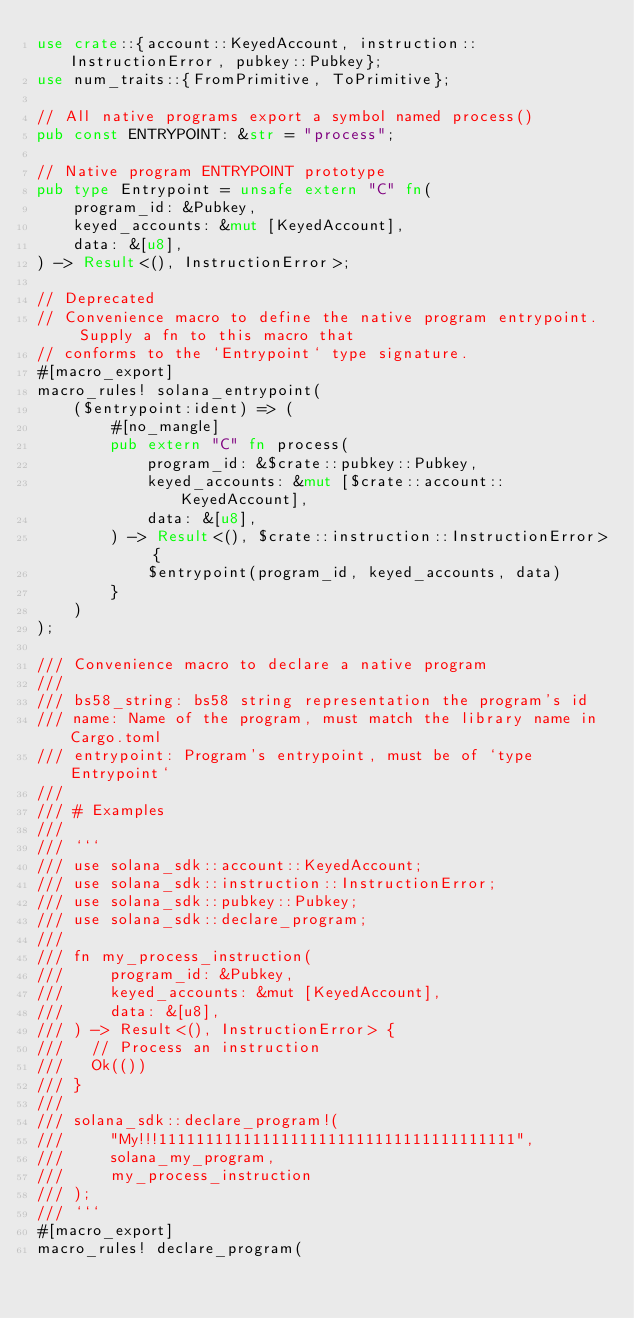<code> <loc_0><loc_0><loc_500><loc_500><_Rust_>use crate::{account::KeyedAccount, instruction::InstructionError, pubkey::Pubkey};
use num_traits::{FromPrimitive, ToPrimitive};

// All native programs export a symbol named process()
pub const ENTRYPOINT: &str = "process";

// Native program ENTRYPOINT prototype
pub type Entrypoint = unsafe extern "C" fn(
    program_id: &Pubkey,
    keyed_accounts: &mut [KeyedAccount],
    data: &[u8],
) -> Result<(), InstructionError>;

// Deprecated
// Convenience macro to define the native program entrypoint.  Supply a fn to this macro that
// conforms to the `Entrypoint` type signature.
#[macro_export]
macro_rules! solana_entrypoint(
    ($entrypoint:ident) => (
        #[no_mangle]
        pub extern "C" fn process(
            program_id: &$crate::pubkey::Pubkey,
            keyed_accounts: &mut [$crate::account::KeyedAccount],
            data: &[u8],
        ) -> Result<(), $crate::instruction::InstructionError> {
            $entrypoint(program_id, keyed_accounts, data)
        }
    )
);

/// Convenience macro to declare a native program
///
/// bs58_string: bs58 string representation the program's id
/// name: Name of the program, must match the library name in Cargo.toml
/// entrypoint: Program's entrypoint, must be of `type Entrypoint`
///
/// # Examples
///
/// ```
/// use solana_sdk::account::KeyedAccount;
/// use solana_sdk::instruction::InstructionError;
/// use solana_sdk::pubkey::Pubkey;
/// use solana_sdk::declare_program;
///
/// fn my_process_instruction(
///     program_id: &Pubkey,
///     keyed_accounts: &mut [KeyedAccount],
///     data: &[u8],
/// ) -> Result<(), InstructionError> {
///   // Process an instruction
///   Ok(())
/// }
///
/// solana_sdk::declare_program!(
///     "My!!!11111111111111111111111111111111111111",
///     solana_my_program,
///     my_process_instruction
/// );
/// ```
#[macro_export]
macro_rules! declare_program(</code> 